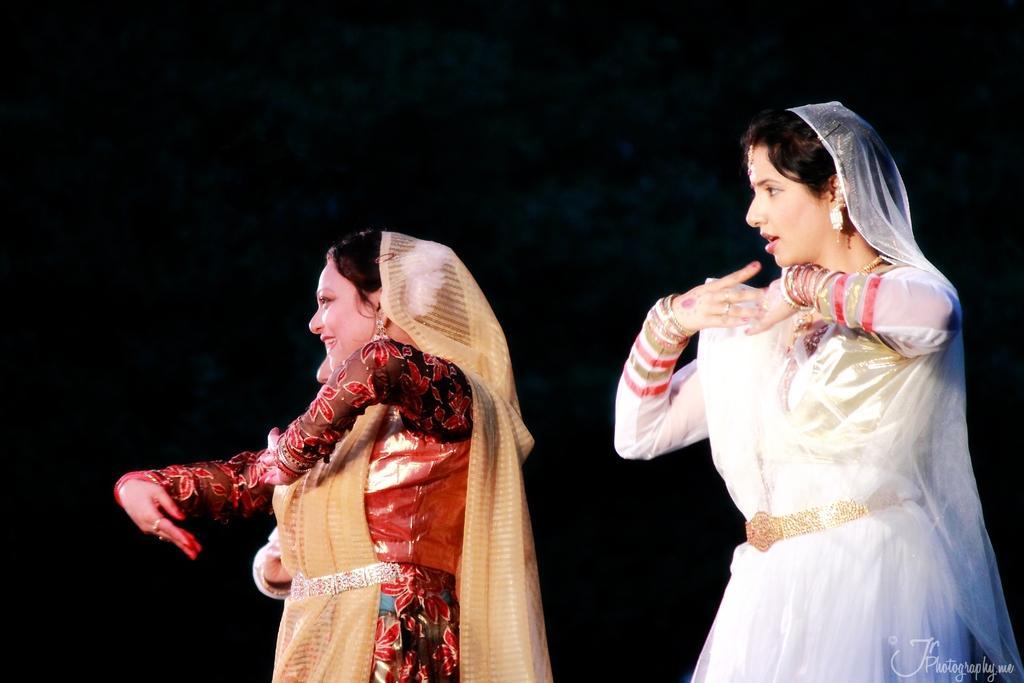How would you summarize this image in a sentence or two? In this image I can see three persons dancing and they are wearing multi color dresses and I can see the dark background. 